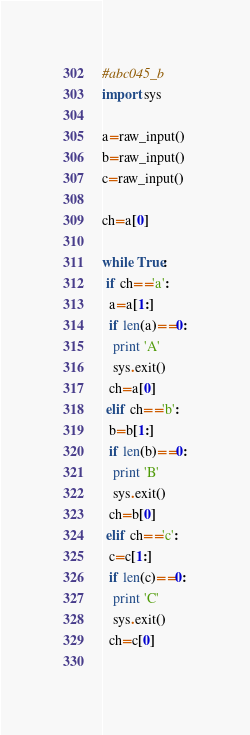<code> <loc_0><loc_0><loc_500><loc_500><_Python_>#abc045_b
import sys

a=raw_input()
b=raw_input()
c=raw_input()

ch=a[0]

while True:
 if ch=='a':
  a=a[1:]
  if len(a)==0:
   print 'A'
   sys.exit()
  ch=a[0]
 elif ch=='b':
  b=b[1:]
  if len(b)==0:
   print 'B'
   sys.exit()
  ch=b[0]
 elif ch=='c':
  c=c[1:]
  if len(c)==0:
   print 'C'
   sys.exit()
  ch=c[0]
 </code> 